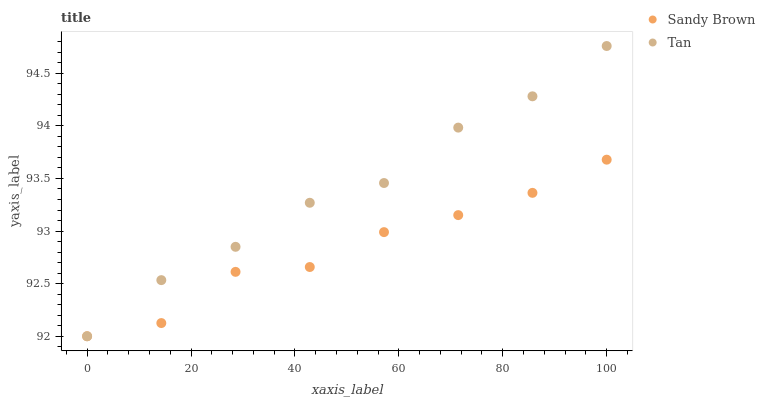Does Sandy Brown have the minimum area under the curve?
Answer yes or no. Yes. Does Tan have the maximum area under the curve?
Answer yes or no. Yes. Does Sandy Brown have the maximum area under the curve?
Answer yes or no. No. Is Tan the smoothest?
Answer yes or no. Yes. Is Sandy Brown the roughest?
Answer yes or no. Yes. Is Sandy Brown the smoothest?
Answer yes or no. No. Does Tan have the lowest value?
Answer yes or no. Yes. Does Tan have the highest value?
Answer yes or no. Yes. Does Sandy Brown have the highest value?
Answer yes or no. No. Does Sandy Brown intersect Tan?
Answer yes or no. Yes. Is Sandy Brown less than Tan?
Answer yes or no. No. Is Sandy Brown greater than Tan?
Answer yes or no. No. 